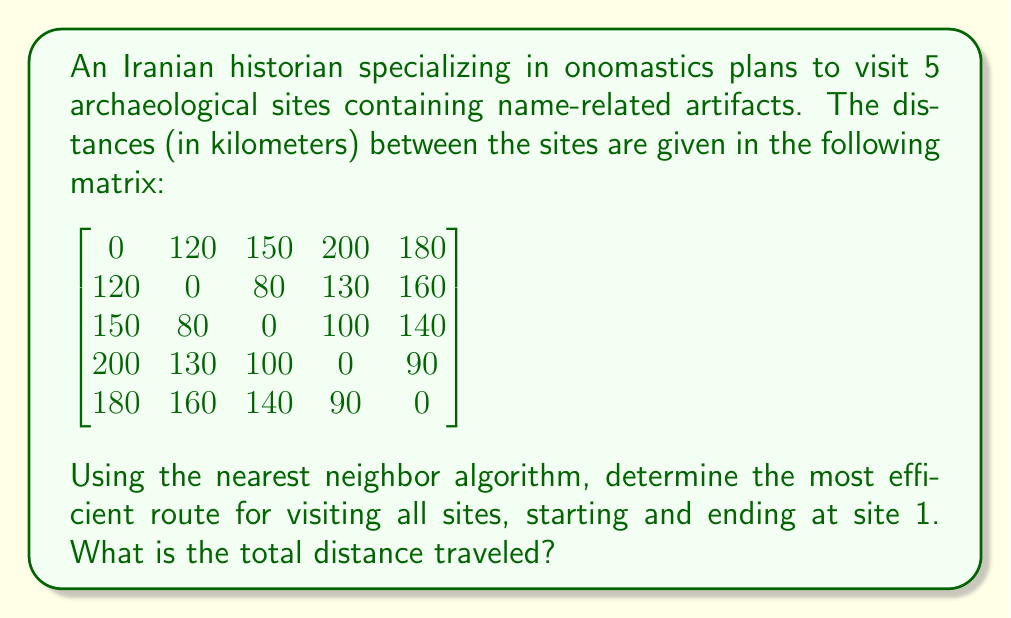Can you answer this question? To solve this problem using the nearest neighbor algorithm, we follow these steps:

1. Start at site 1.
2. Find the nearest unvisited site and move to it.
3. Repeat step 2 until all sites have been visited.
4. Return to site 1.

Let's apply the algorithm:

1. Start at site 1.

2. From site 1, the nearest site is site 2 (120 km). Move to site 2.
   Distance so far: 120 km

3. From site 2, the nearest unvisited site is site 3 (80 km). Move to site 3.
   Distance so far: 120 + 80 = 200 km

4. From site 3, the nearest unvisited site is site 4 (100 km). Move to site 4.
   Distance so far: 200 + 100 = 300 km

5. From site 4, the only unvisited site is site 5 (90 km). Move to site 5.
   Distance so far: 300 + 90 = 390 km

6. Return to site 1 from site 5 (180 km).
   Total distance: 390 + 180 = 570 km

Therefore, the route is: 1 → 2 → 3 → 4 → 5 → 1

The total distance traveled is 570 km.
Answer: The most efficient route using the nearest neighbor algorithm is 1 → 2 → 3 → 4 → 5 → 1, with a total distance of 570 km. 